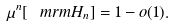Convert formula to latex. <formula><loc_0><loc_0><loc_500><loc_500>\mu ^ { n } [ \ m r m H _ { n } ] = 1 - o ( 1 ) .</formula> 